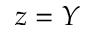Convert formula to latex. <formula><loc_0><loc_0><loc_500><loc_500>z = Y</formula> 